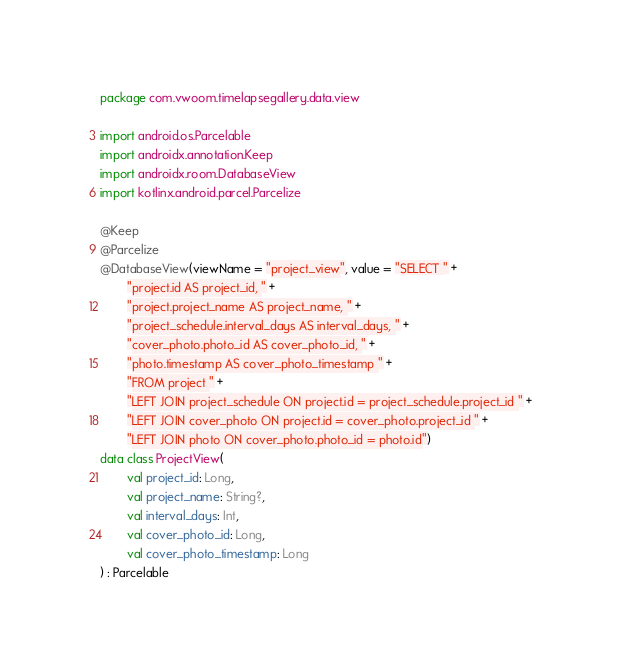<code> <loc_0><loc_0><loc_500><loc_500><_Kotlin_>package com.vwoom.timelapsegallery.data.view

import android.os.Parcelable
import androidx.annotation.Keep
import androidx.room.DatabaseView
import kotlinx.android.parcel.Parcelize

@Keep
@Parcelize
@DatabaseView(viewName = "project_view", value = "SELECT " +
        "project.id AS project_id, " +
        "project.project_name AS project_name, " +
        "project_schedule.interval_days AS interval_days, " +
        "cover_photo.photo_id AS cover_photo_id, " +
        "photo.timestamp AS cover_photo_timestamp " +
        "FROM project " +
        "LEFT JOIN project_schedule ON project.id = project_schedule.project_id " +
        "LEFT JOIN cover_photo ON project.id = cover_photo.project_id " +
        "LEFT JOIN photo ON cover_photo.photo_id = photo.id")
data class ProjectView(
        val project_id: Long,
        val project_name: String?,
        val interval_days: Int,
        val cover_photo_id: Long,
        val cover_photo_timestamp: Long
) : Parcelable
</code> 